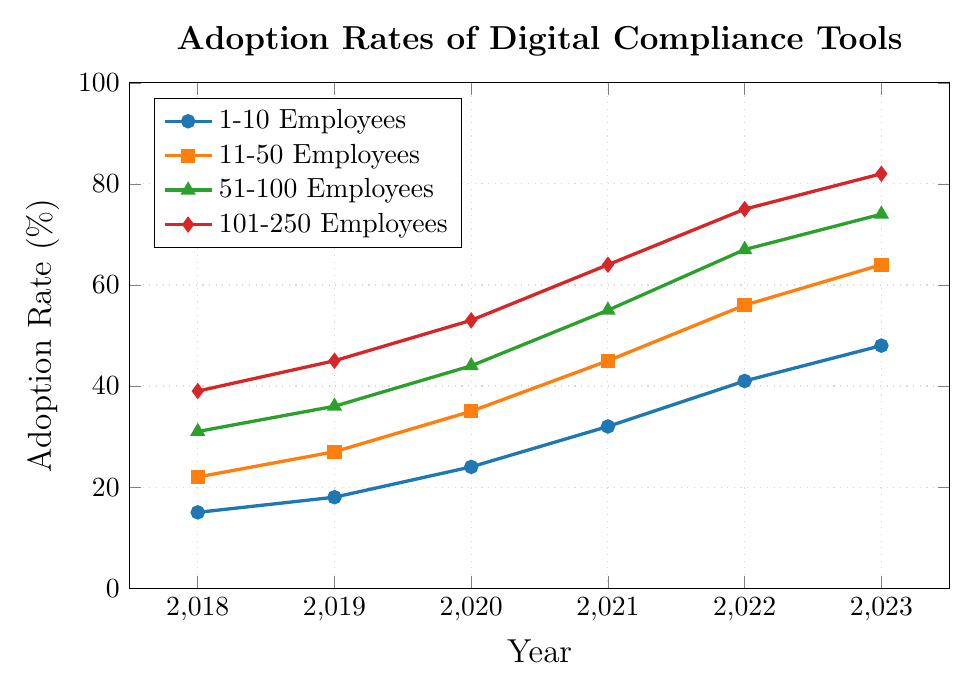What year did the smallest businesses (1-10 Employees) have the highest adoption rate? The highest point for the 1-10 Employees line on the chart occurs in 2023. Thus, the highest adoption rate for this group was in that year.
Answer: 2023 Which business size group showed the greatest increase in adoption rate from 2018 to 2023? To determine this, we calculate the increase for each group as the difference between their 2023 and 2018 adoption rates: 1-10 Employees: 48% - 15% = 33%, 11-50 Employees: 64% - 22% = 42%, 51-100 Employees: 74% - 31% = 43%, 101-250 Employees: 82% - 39% = 43%. The groups 51-100 Employees and 101-250 Employees showed the greatest increase.
Answer: 51-100 Employees and 101-250 Employees By how much did the adoption rate for businesses with 11-50 Employees increase from 2020 to 2022? The difference in adoption rates for the 11-50 Employees group between 2020 and 2022 is 56% - 35% = 21%.
Answer: 21% Which year saw the greatest year-over-year increase for businesses with 101-250 Employees, and what was the increase? For the 101-250 Employees group, the year-over-year increases are: 2018-2019: 45% - 39% = 6%, 2019-2020: 53% - 45% = 8%, 2020-2021: 64% - 53% = 11%, 2021-2022: 75% - 64% = 11%, 2022-2023: 82% - 75% = 7%. The years 2020-2021 and 2021-2022 both saw the greatest increase of 11%.
Answer: 2021 and 2022, 11% Among the four business sizes, which consistently had the highest adoption rates across all years? By comparing the lines on the chart, the group with 101-250 Employees consistently had the highest adoption rates from 2018 to 2023.
Answer: 101-250 Employees Which group had the smallest adoption rate in 2021, and what was the rate? The smallest adoption rate in 2021 can be observed by looking at the y-values of all lines in that year. The 1-10 Employees group had the smallest rate with 32%.
Answer: 1-10 Employees, 32% What is the average adoption rate for businesses with 51-100 Employees between 2018 and 2023? The average is calculated by summing the adoption rates for each year and dividing by the number of years: (31% + 36% + 44% + 55% + 67% + 74%) / 6 = 51.167%.
Answer: 51.167% How did the adoption rate change for the smallest businesses from 2019 to 2020, and was this change greater than the change from 2021 to 2022 for the same group? From 2019 to 2020, the change was 24% - 18% = 6%. From 2021 to 2022, the change was 41% - 32% = 9%. Comparing both values, the change from 2021 to 2022 was greater.
Answer: Yes, 2022 (9%) was greater than 2020 (6%) What was the adoption rate for the 11-50 Employees group in 2019, and how does it compare to the adoption rate of the 1-10 Employees group in 2021? The adoption rate for the 11-50 Employees group in 2019 was 27%, while the adoption rate for the 1-10 Employees group in 2021 was 32%. By comparing the two, the rate was higher in 2021 for the 1-10 Employees group.
Answer: 11-50 Employees in 2019: 27%, 1-10 Employees in 2021: 32% What is the difference in adoption rates between the largest and the smallest businesses in 2023? The adoption rate for the 101-250 Employees group in 2023 is 82%, and for the 1-10 Employees group, it is 48%. The difference is 82% - 48% = 34%.
Answer: 34% 